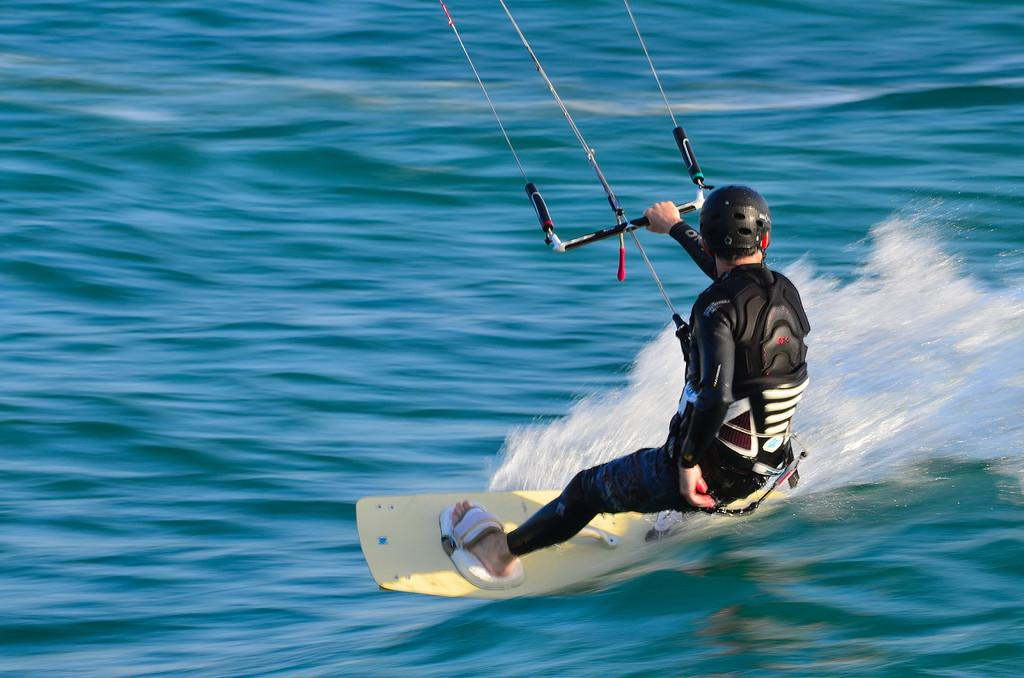Who is present in the image? There is a person in the image. What is the person wearing? The person is wearing a black color uniform. What activity is the person engaged in? The person is surfing in water. What company does the person work for, as indicated by their uniform in the image? There is no indication of a company or any text on the uniform in the image. 